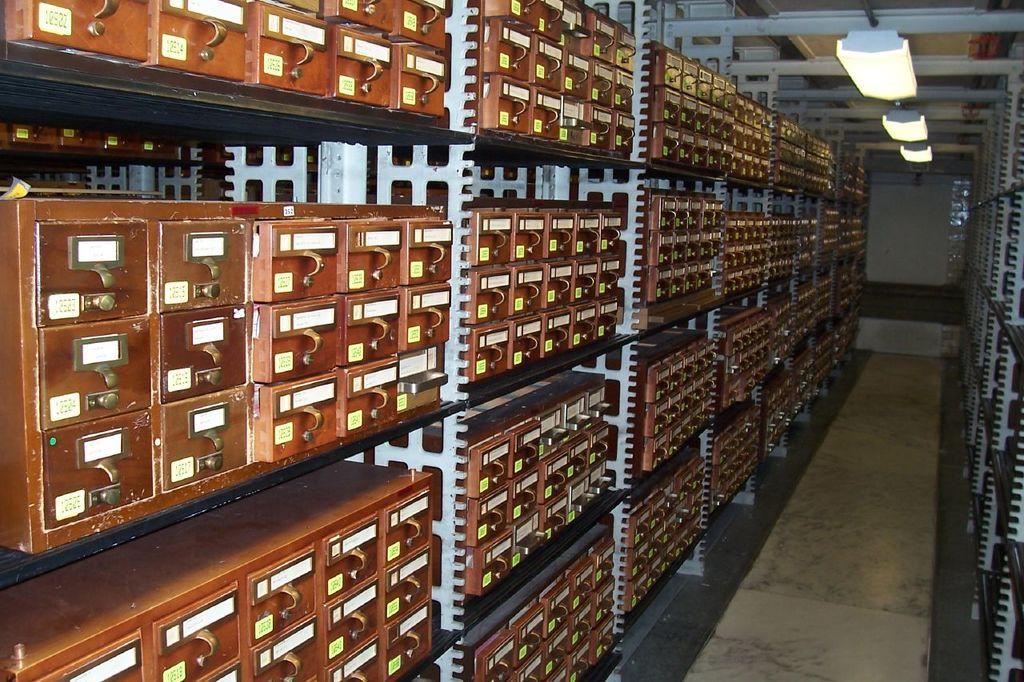How would you summarize this image in a sentence or two? In this image I can see few wooden boxes and they are in the racks. Background I can see few lights. 